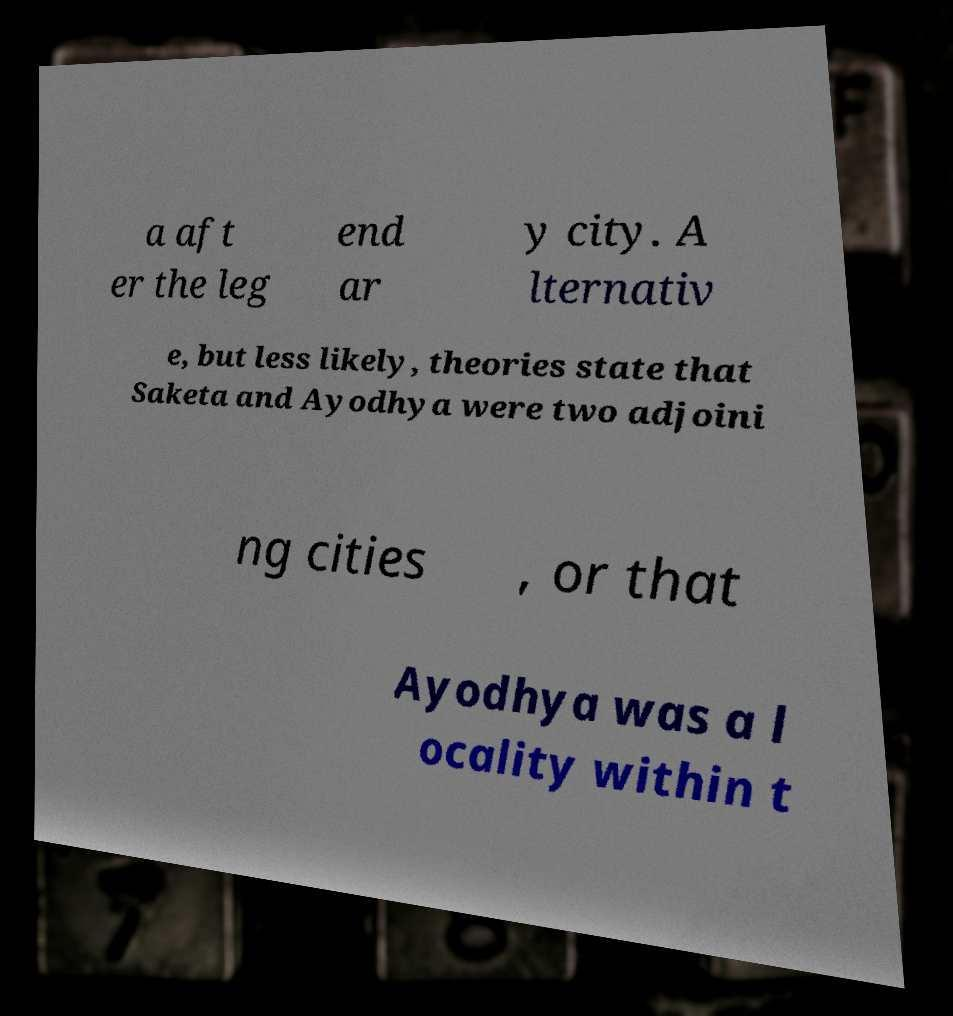There's text embedded in this image that I need extracted. Can you transcribe it verbatim? a aft er the leg end ar y city. A lternativ e, but less likely, theories state that Saketa and Ayodhya were two adjoini ng cities , or that Ayodhya was a l ocality within t 